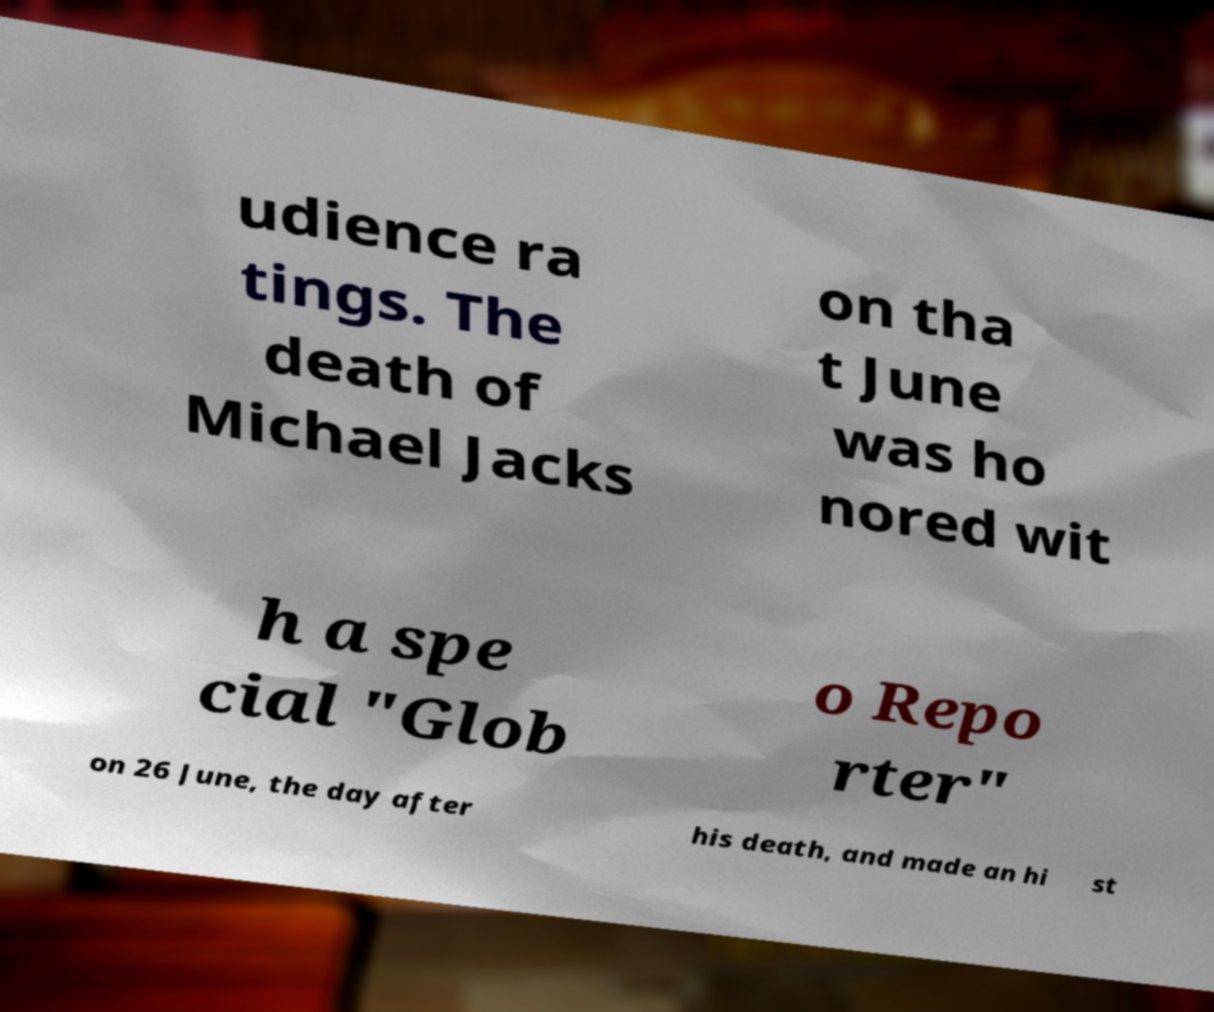Please read and relay the text visible in this image. What does it say? udience ra tings. The death of Michael Jacks on tha t June was ho nored wit h a spe cial "Glob o Repo rter" on 26 June, the day after his death, and made an hi st 